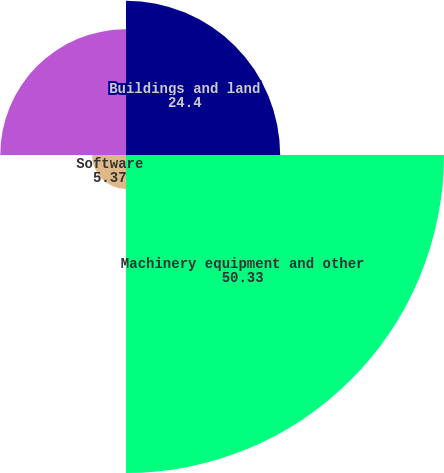<chart> <loc_0><loc_0><loc_500><loc_500><pie_chart><fcel>Buildings and land<fcel>Machinery equipment and other<fcel>Software<fcel>Equipment leased to others<nl><fcel>24.4%<fcel>50.33%<fcel>5.37%<fcel>19.9%<nl></chart> 